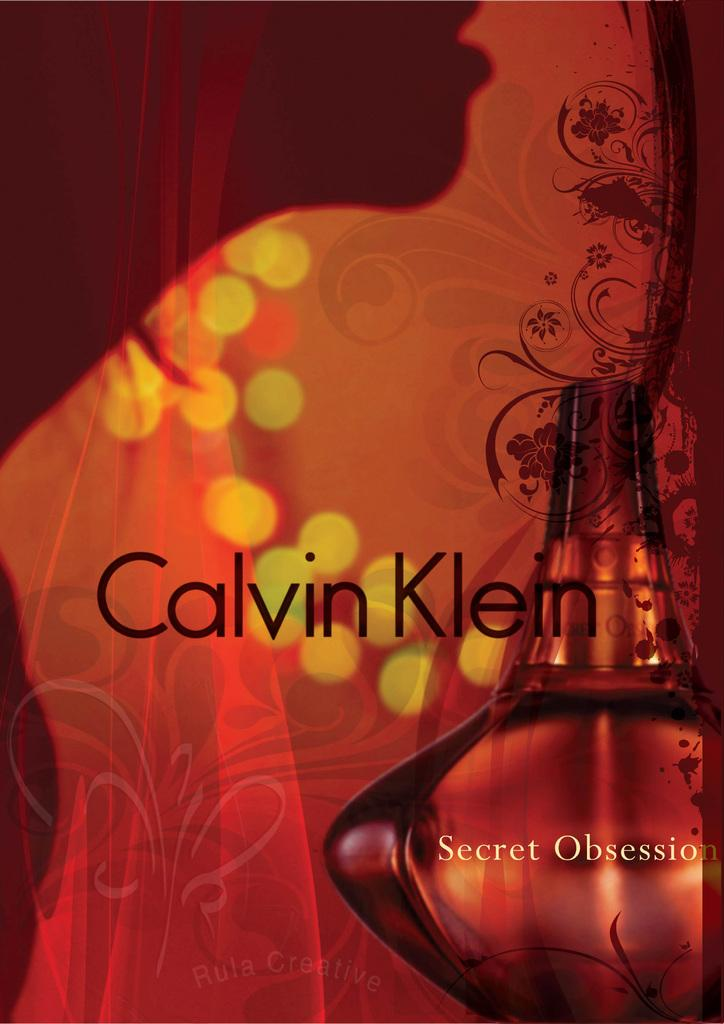<image>
Relay a brief, clear account of the picture shown. A poster for the Calvin Klein fragrance Secret Obsession shows the silhouette of a woman's mouth and neck. 